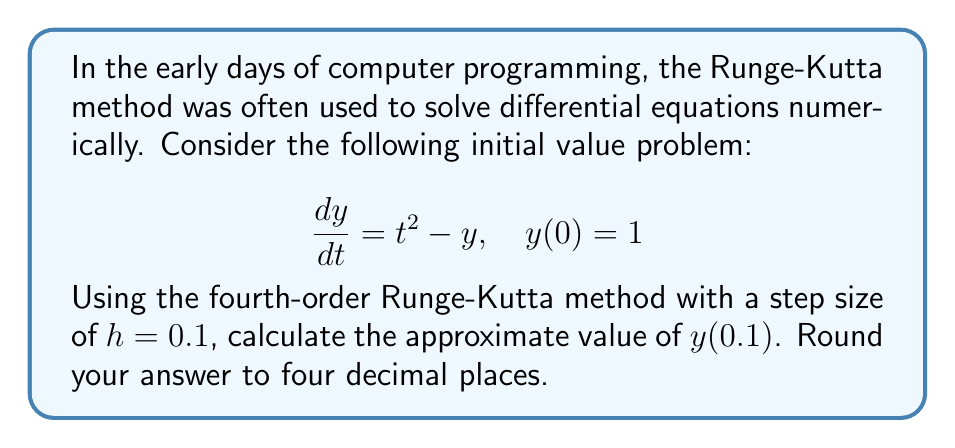Can you solve this math problem? The fourth-order Runge-Kutta method for solving differential equations is given by:

$$y_{n+1} = y_n + \frac{1}{6}(k_1 + 2k_2 + 2k_3 + k_4)$$

Where:
$$\begin{align*}
k_1 &= hf(t_n, y_n) \\
k_2 &= hf(t_n + \frac{h}{2}, y_n + \frac{k_1}{2}) \\
k_3 &= hf(t_n + \frac{h}{2}, y_n + \frac{k_2}{2}) \\
k_4 &= hf(t_n + h, y_n + k_3)
\end{align*}$$

For our problem, $f(t, y) = t^2 - y$, $h = 0.1$, $t_0 = 0$, and $y_0 = 1$.

Let's calculate each $k$ value:

1) $k_1 = h(t_0^2 - y_0) = 0.1(0^2 - 1) = -0.1$

2) $k_2 = h((t_0 + \frac{h}{2})^2 - (y_0 + \frac{k_1}{2}))$
   $= 0.1((0 + 0.05)^2 - (1 - 0.05)) = -0.094875$

3) $k_3 = h((t_0 + \frac{h}{2})^2 - (y_0 + \frac{k_2}{2}))$
   $= 0.1((0 + 0.05)^2 - (1 - 0.0474375)) = -0.0949375$

4) $k_4 = h((t_0 + h)^2 - (y_0 + k_3))$
   $= 0.1((0 + 0.1)^2 - (1 - 0.0949375)) = -0.0895$

Now we can calculate $y_1$:

$$\begin{align*}
y_1 &= y_0 + \frac{1}{6}(k_1 + 2k_2 + 2k_3 + k_4) \\
&= 1 + \frac{1}{6}(-0.1 + 2(-0.094875) + 2(-0.0949375) + (-0.0895)) \\
&= 1 - 0.0948125 \\
&= 0.9051875
\end{align*}$$

Rounding to four decimal places, we get 0.9052.
Answer: 0.9052 